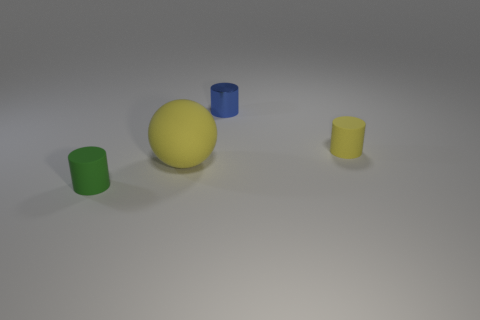Is there any other thing that is the same material as the small blue cylinder?
Make the answer very short. No. There is a yellow object that is on the left side of the small blue shiny cylinder; is it the same shape as the tiny green thing?
Your response must be concise. No. What material is the big sphere that is behind the small green matte cylinder?
Your response must be concise. Rubber. Is there a tiny brown object that has the same material as the yellow ball?
Your answer should be very brief. No. The blue cylinder is what size?
Provide a succinct answer. Small. How many purple objects are either cylinders or rubber things?
Offer a terse response. 0. What number of yellow objects are the same shape as the small green matte thing?
Keep it short and to the point. 1. What number of green cylinders have the same size as the blue cylinder?
Give a very brief answer. 1. What is the material of the tiny yellow thing that is the same shape as the green rubber object?
Provide a succinct answer. Rubber. The matte object in front of the sphere is what color?
Give a very brief answer. Green. 